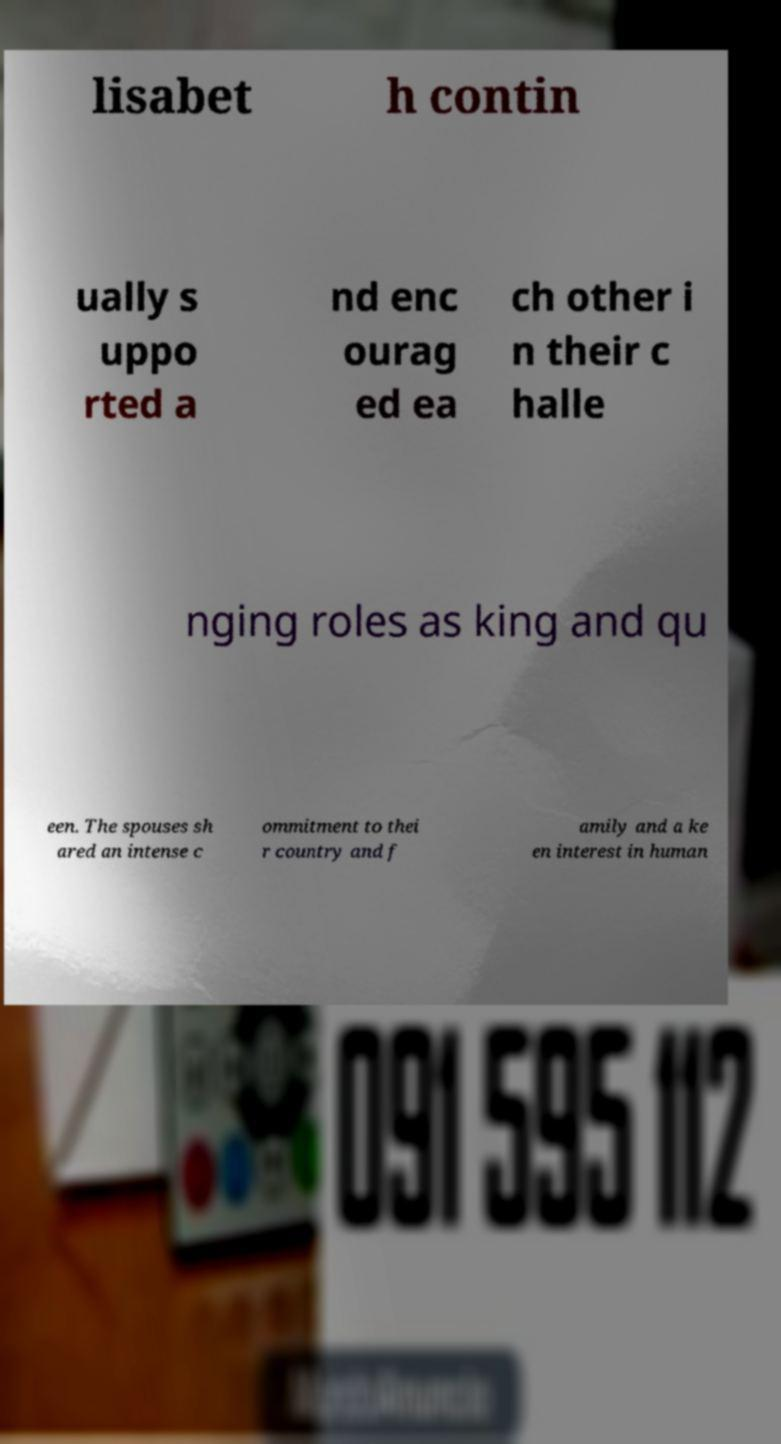Can you accurately transcribe the text from the provided image for me? lisabet h contin ually s uppo rted a nd enc ourag ed ea ch other i n their c halle nging roles as king and qu een. The spouses sh ared an intense c ommitment to thei r country and f amily and a ke en interest in human 